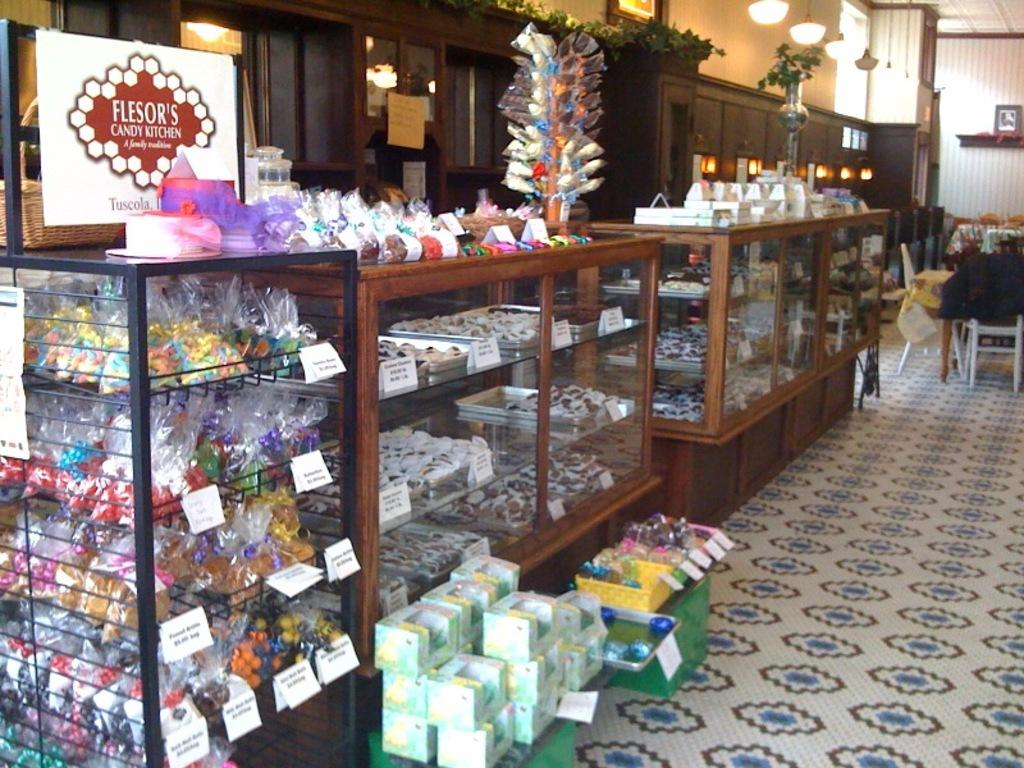Provide a one-sentence caption for the provided image. A candy stand with a sign for Flesor's Candy Kitchen above it. 